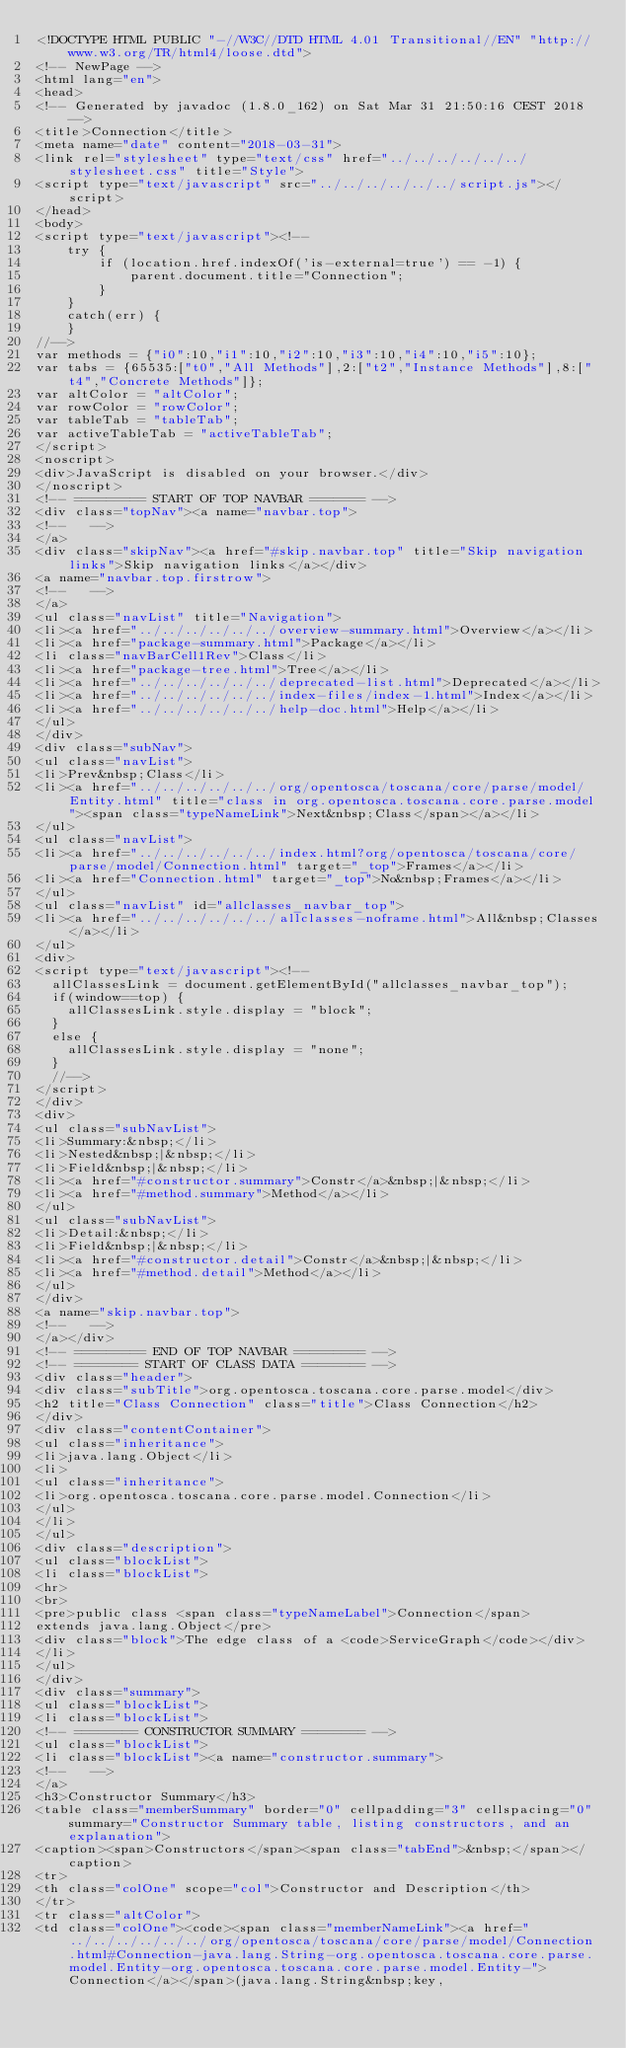<code> <loc_0><loc_0><loc_500><loc_500><_HTML_><!DOCTYPE HTML PUBLIC "-//W3C//DTD HTML 4.01 Transitional//EN" "http://www.w3.org/TR/html4/loose.dtd">
<!-- NewPage -->
<html lang="en">
<head>
<!-- Generated by javadoc (1.8.0_162) on Sat Mar 31 21:50:16 CEST 2018 -->
<title>Connection</title>
<meta name="date" content="2018-03-31">
<link rel="stylesheet" type="text/css" href="../../../../../../stylesheet.css" title="Style">
<script type="text/javascript" src="../../../../../../script.js"></script>
</head>
<body>
<script type="text/javascript"><!--
    try {
        if (location.href.indexOf('is-external=true') == -1) {
            parent.document.title="Connection";
        }
    }
    catch(err) {
    }
//-->
var methods = {"i0":10,"i1":10,"i2":10,"i3":10,"i4":10,"i5":10};
var tabs = {65535:["t0","All Methods"],2:["t2","Instance Methods"],8:["t4","Concrete Methods"]};
var altColor = "altColor";
var rowColor = "rowColor";
var tableTab = "tableTab";
var activeTableTab = "activeTableTab";
</script>
<noscript>
<div>JavaScript is disabled on your browser.</div>
</noscript>
<!-- ========= START OF TOP NAVBAR ======= -->
<div class="topNav"><a name="navbar.top">
<!--   -->
</a>
<div class="skipNav"><a href="#skip.navbar.top" title="Skip navigation links">Skip navigation links</a></div>
<a name="navbar.top.firstrow">
<!--   -->
</a>
<ul class="navList" title="Navigation">
<li><a href="../../../../../../overview-summary.html">Overview</a></li>
<li><a href="package-summary.html">Package</a></li>
<li class="navBarCell1Rev">Class</li>
<li><a href="package-tree.html">Tree</a></li>
<li><a href="../../../../../../deprecated-list.html">Deprecated</a></li>
<li><a href="../../../../../../index-files/index-1.html">Index</a></li>
<li><a href="../../../../../../help-doc.html">Help</a></li>
</ul>
</div>
<div class="subNav">
<ul class="navList">
<li>Prev&nbsp;Class</li>
<li><a href="../../../../../../org/opentosca/toscana/core/parse/model/Entity.html" title="class in org.opentosca.toscana.core.parse.model"><span class="typeNameLink">Next&nbsp;Class</span></a></li>
</ul>
<ul class="navList">
<li><a href="../../../../../../index.html?org/opentosca/toscana/core/parse/model/Connection.html" target="_top">Frames</a></li>
<li><a href="Connection.html" target="_top">No&nbsp;Frames</a></li>
</ul>
<ul class="navList" id="allclasses_navbar_top">
<li><a href="../../../../../../allclasses-noframe.html">All&nbsp;Classes</a></li>
</ul>
<div>
<script type="text/javascript"><!--
  allClassesLink = document.getElementById("allclasses_navbar_top");
  if(window==top) {
    allClassesLink.style.display = "block";
  }
  else {
    allClassesLink.style.display = "none";
  }
  //-->
</script>
</div>
<div>
<ul class="subNavList">
<li>Summary:&nbsp;</li>
<li>Nested&nbsp;|&nbsp;</li>
<li>Field&nbsp;|&nbsp;</li>
<li><a href="#constructor.summary">Constr</a>&nbsp;|&nbsp;</li>
<li><a href="#method.summary">Method</a></li>
</ul>
<ul class="subNavList">
<li>Detail:&nbsp;</li>
<li>Field&nbsp;|&nbsp;</li>
<li><a href="#constructor.detail">Constr</a>&nbsp;|&nbsp;</li>
<li><a href="#method.detail">Method</a></li>
</ul>
</div>
<a name="skip.navbar.top">
<!--   -->
</a></div>
<!-- ========= END OF TOP NAVBAR ========= -->
<!-- ======== START OF CLASS DATA ======== -->
<div class="header">
<div class="subTitle">org.opentosca.toscana.core.parse.model</div>
<h2 title="Class Connection" class="title">Class Connection</h2>
</div>
<div class="contentContainer">
<ul class="inheritance">
<li>java.lang.Object</li>
<li>
<ul class="inheritance">
<li>org.opentosca.toscana.core.parse.model.Connection</li>
</ul>
</li>
</ul>
<div class="description">
<ul class="blockList">
<li class="blockList">
<hr>
<br>
<pre>public class <span class="typeNameLabel">Connection</span>
extends java.lang.Object</pre>
<div class="block">The edge class of a <code>ServiceGraph</code></div>
</li>
</ul>
</div>
<div class="summary">
<ul class="blockList">
<li class="blockList">
<!-- ======== CONSTRUCTOR SUMMARY ======== -->
<ul class="blockList">
<li class="blockList"><a name="constructor.summary">
<!--   -->
</a>
<h3>Constructor Summary</h3>
<table class="memberSummary" border="0" cellpadding="3" cellspacing="0" summary="Constructor Summary table, listing constructors, and an explanation">
<caption><span>Constructors</span><span class="tabEnd">&nbsp;</span></caption>
<tr>
<th class="colOne" scope="col">Constructor and Description</th>
</tr>
<tr class="altColor">
<td class="colOne"><code><span class="memberNameLink"><a href="../../../../../../org/opentosca/toscana/core/parse/model/Connection.html#Connection-java.lang.String-org.opentosca.toscana.core.parse.model.Entity-org.opentosca.toscana.core.parse.model.Entity-">Connection</a></span>(java.lang.String&nbsp;key,</code> 